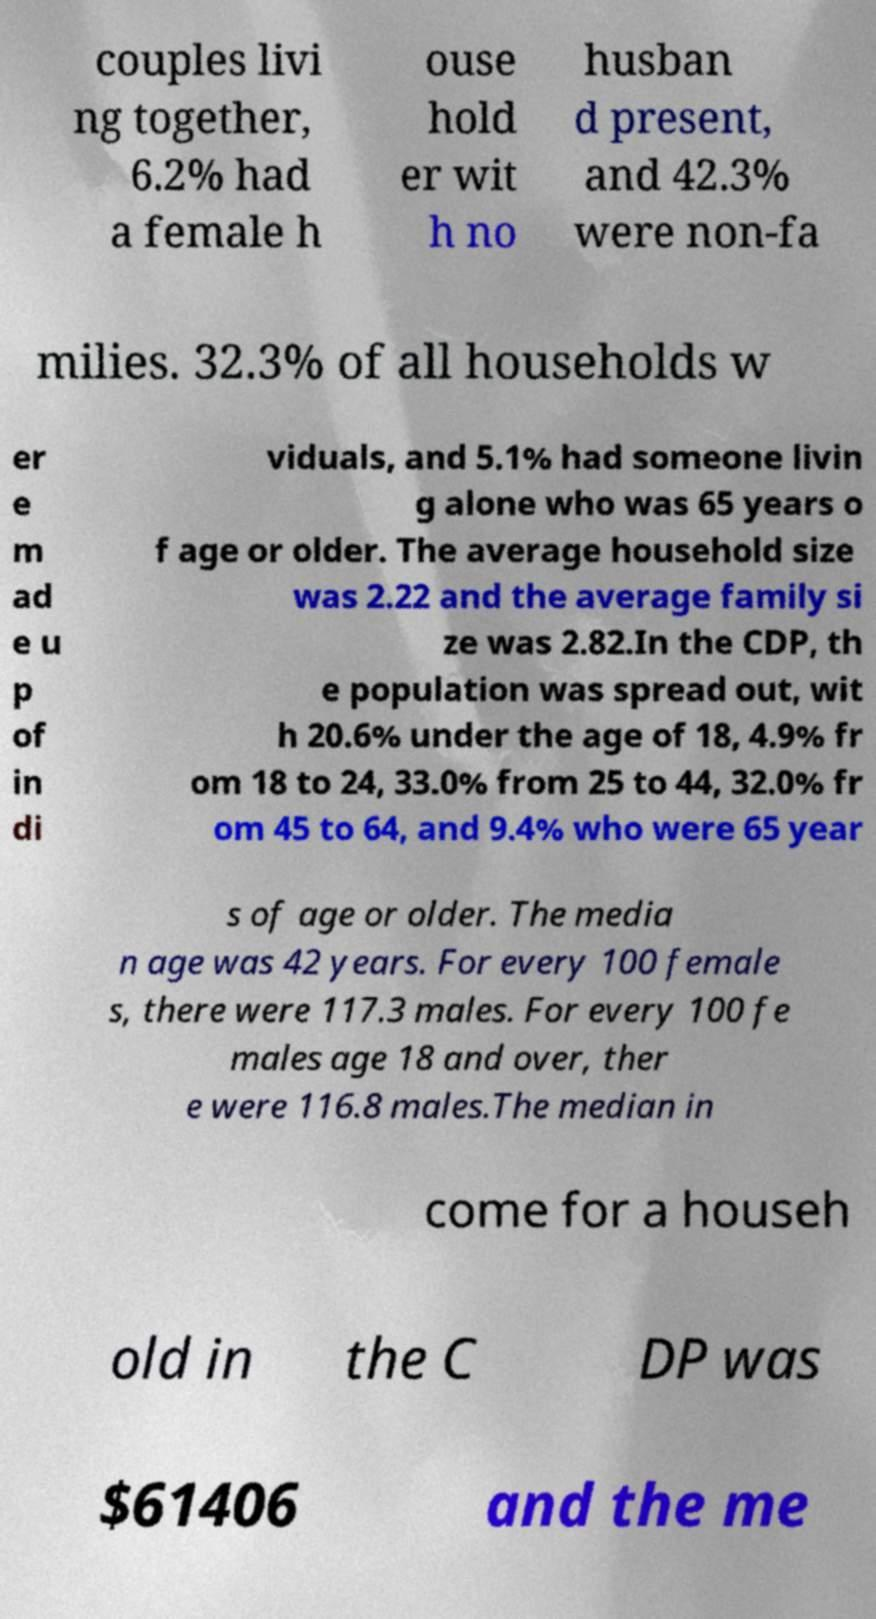Can you read and provide the text displayed in the image?This photo seems to have some interesting text. Can you extract and type it out for me? couples livi ng together, 6.2% had a female h ouse hold er wit h no husban d present, and 42.3% were non-fa milies. 32.3% of all households w er e m ad e u p of in di viduals, and 5.1% had someone livin g alone who was 65 years o f age or older. The average household size was 2.22 and the average family si ze was 2.82.In the CDP, th e population was spread out, wit h 20.6% under the age of 18, 4.9% fr om 18 to 24, 33.0% from 25 to 44, 32.0% fr om 45 to 64, and 9.4% who were 65 year s of age or older. The media n age was 42 years. For every 100 female s, there were 117.3 males. For every 100 fe males age 18 and over, ther e were 116.8 males.The median in come for a househ old in the C DP was $61406 and the me 